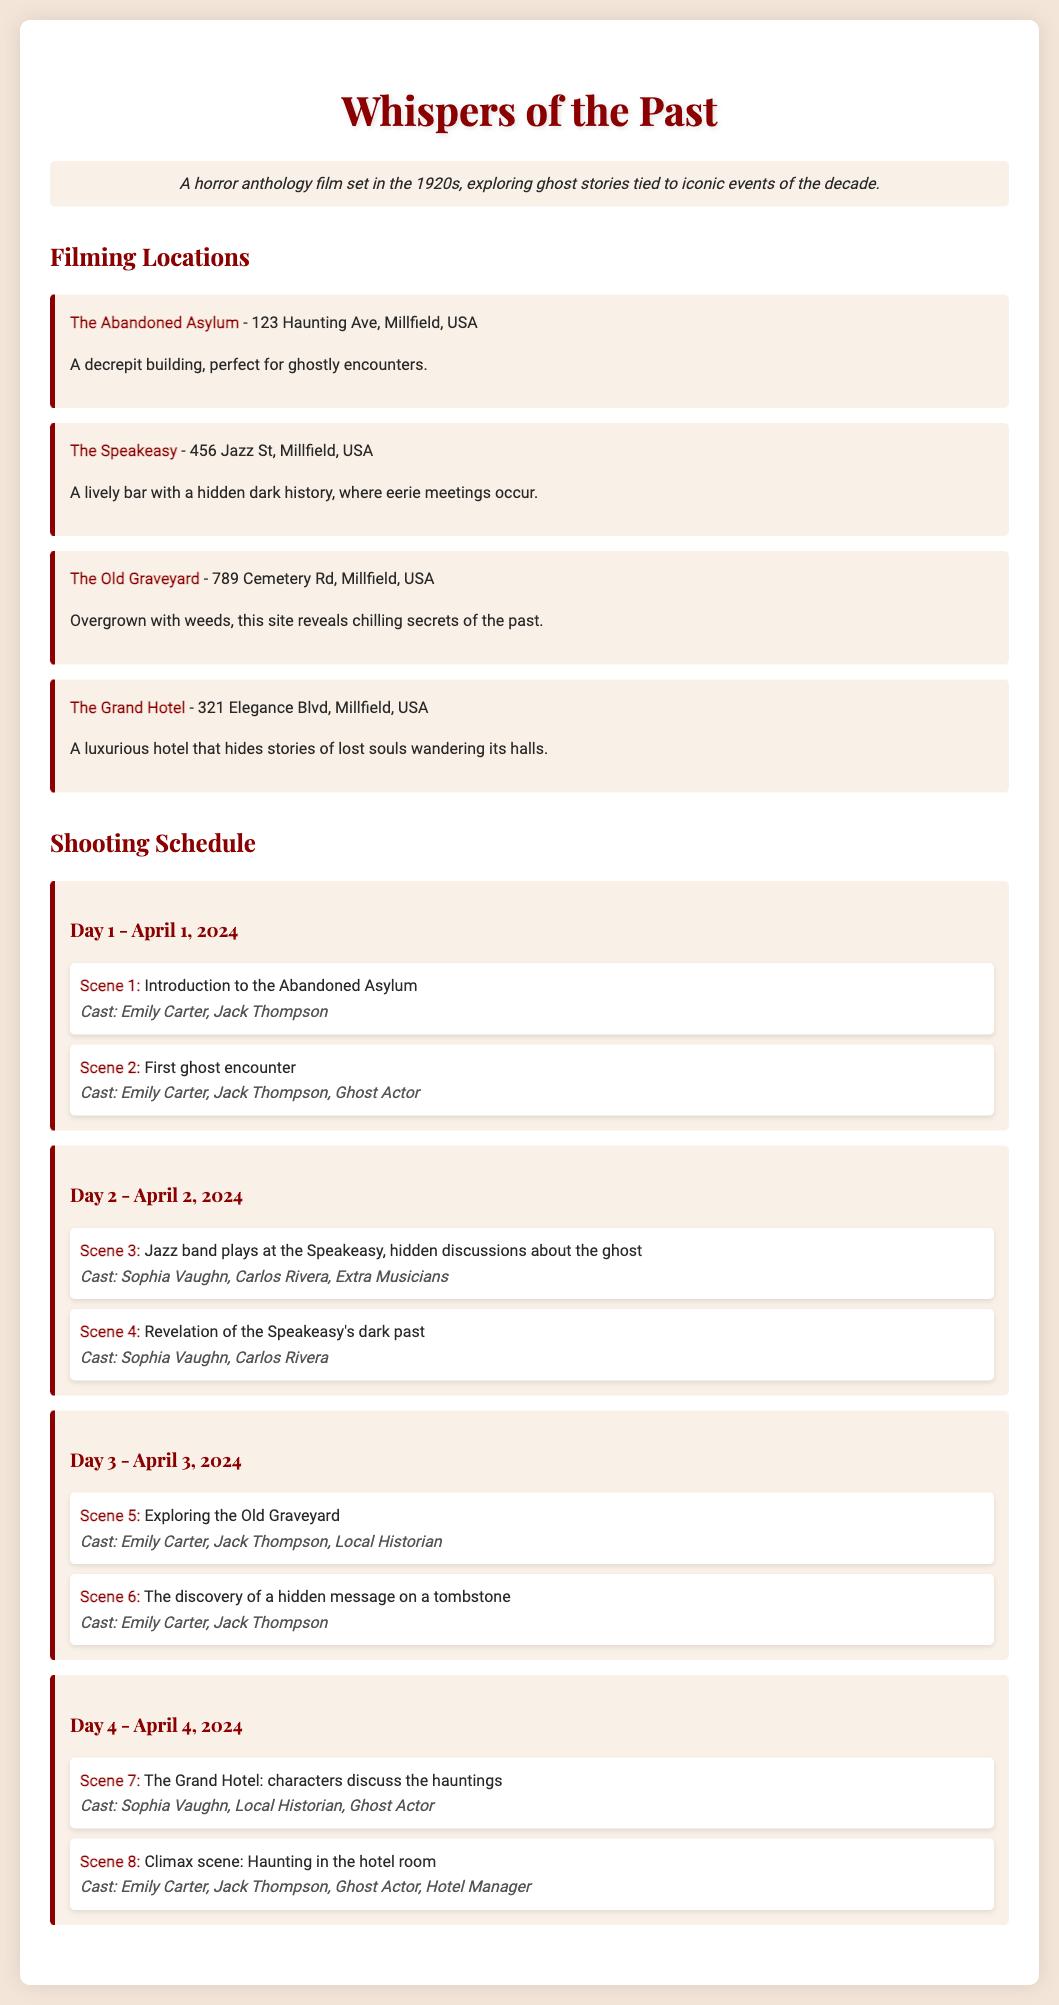What is the title of the film? The title of the film is prominently displayed at the top of the document as part of the heading.
Answer: Whispers of the Past When does filming start? The starting date of filming is noted in the shooting schedule under Day 1.
Answer: April 1, 2024 How many scenes are scheduled for Day 2? The number of scenes scheduled for Day 2 can be counted in the corresponding section of the shooting schedule.
Answer: 2 What location is used for the climax scene? The specific location for the climax scene is mentioned in the schedule for Day 4.
Answer: The Grand Hotel Who are the actors in Scene 6? The cast for Scene 6 is listed, providing the names of those involved in that particular scene.
Answer: Emily Carter, Jack Thompson What is the address of The Abandoned Asylum? The address can be found in the locations section for The Abandoned Asylum.
Answer: 123 Haunting Ave, Millfield, USA Which character is associated with the Speakeasy's dark past revelation? The character associated with this scene is identified in the casting for Scene 4.
Answer: Sophia Vaughn Which day features the exploration of the Old Graveyard? The day of the exploration is specified in the shooting schedule.
Answer: Day 3 